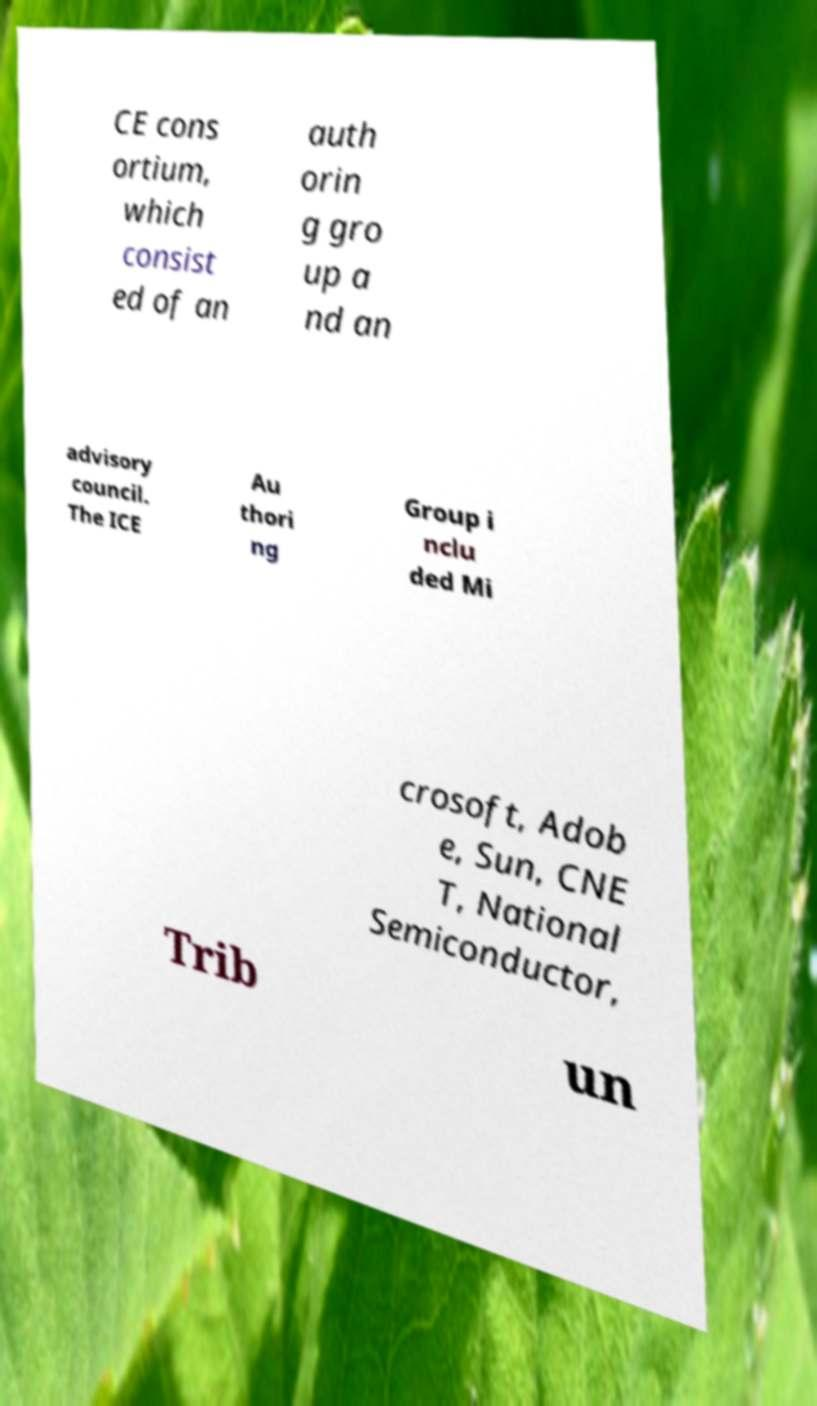Can you accurately transcribe the text from the provided image for me? CE cons ortium, which consist ed of an auth orin g gro up a nd an advisory council. The ICE Au thori ng Group i nclu ded Mi crosoft, Adob e, Sun, CNE T, National Semiconductor, Trib un 